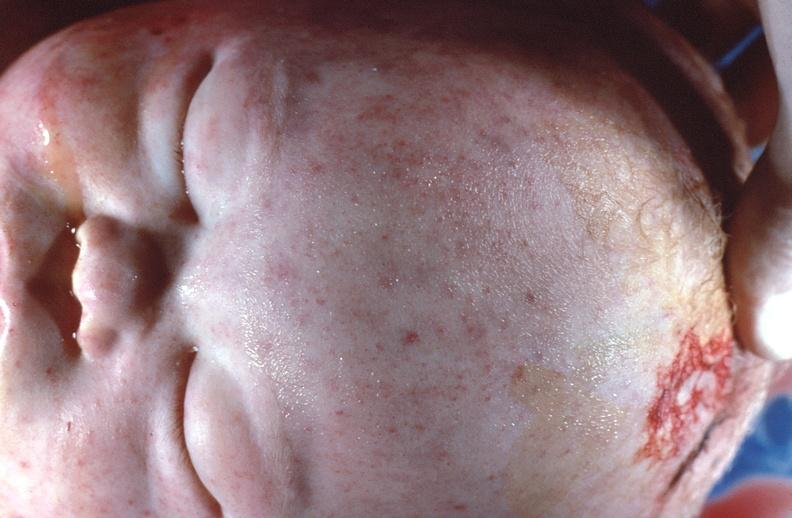does this image show gram negative septicemia due to scalp electrode in a neonate?
Answer the question using a single word or phrase. Yes 